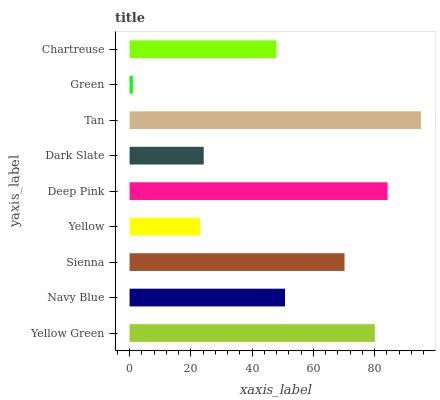Is Green the minimum?
Answer yes or no. Yes. Is Tan the maximum?
Answer yes or no. Yes. Is Navy Blue the minimum?
Answer yes or no. No. Is Navy Blue the maximum?
Answer yes or no. No. Is Yellow Green greater than Navy Blue?
Answer yes or no. Yes. Is Navy Blue less than Yellow Green?
Answer yes or no. Yes. Is Navy Blue greater than Yellow Green?
Answer yes or no. No. Is Yellow Green less than Navy Blue?
Answer yes or no. No. Is Navy Blue the high median?
Answer yes or no. Yes. Is Navy Blue the low median?
Answer yes or no. Yes. Is Deep Pink the high median?
Answer yes or no. No. Is Green the low median?
Answer yes or no. No. 